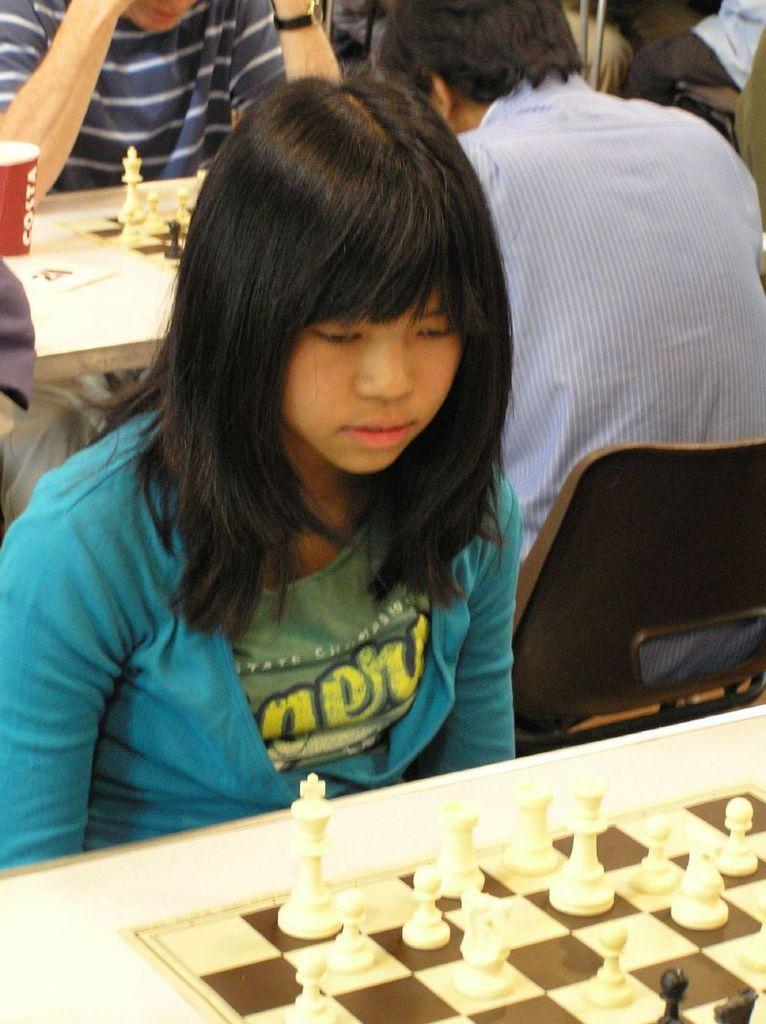Describe this image in one or two sentences. people are sitting. in front of them there is chess board. 